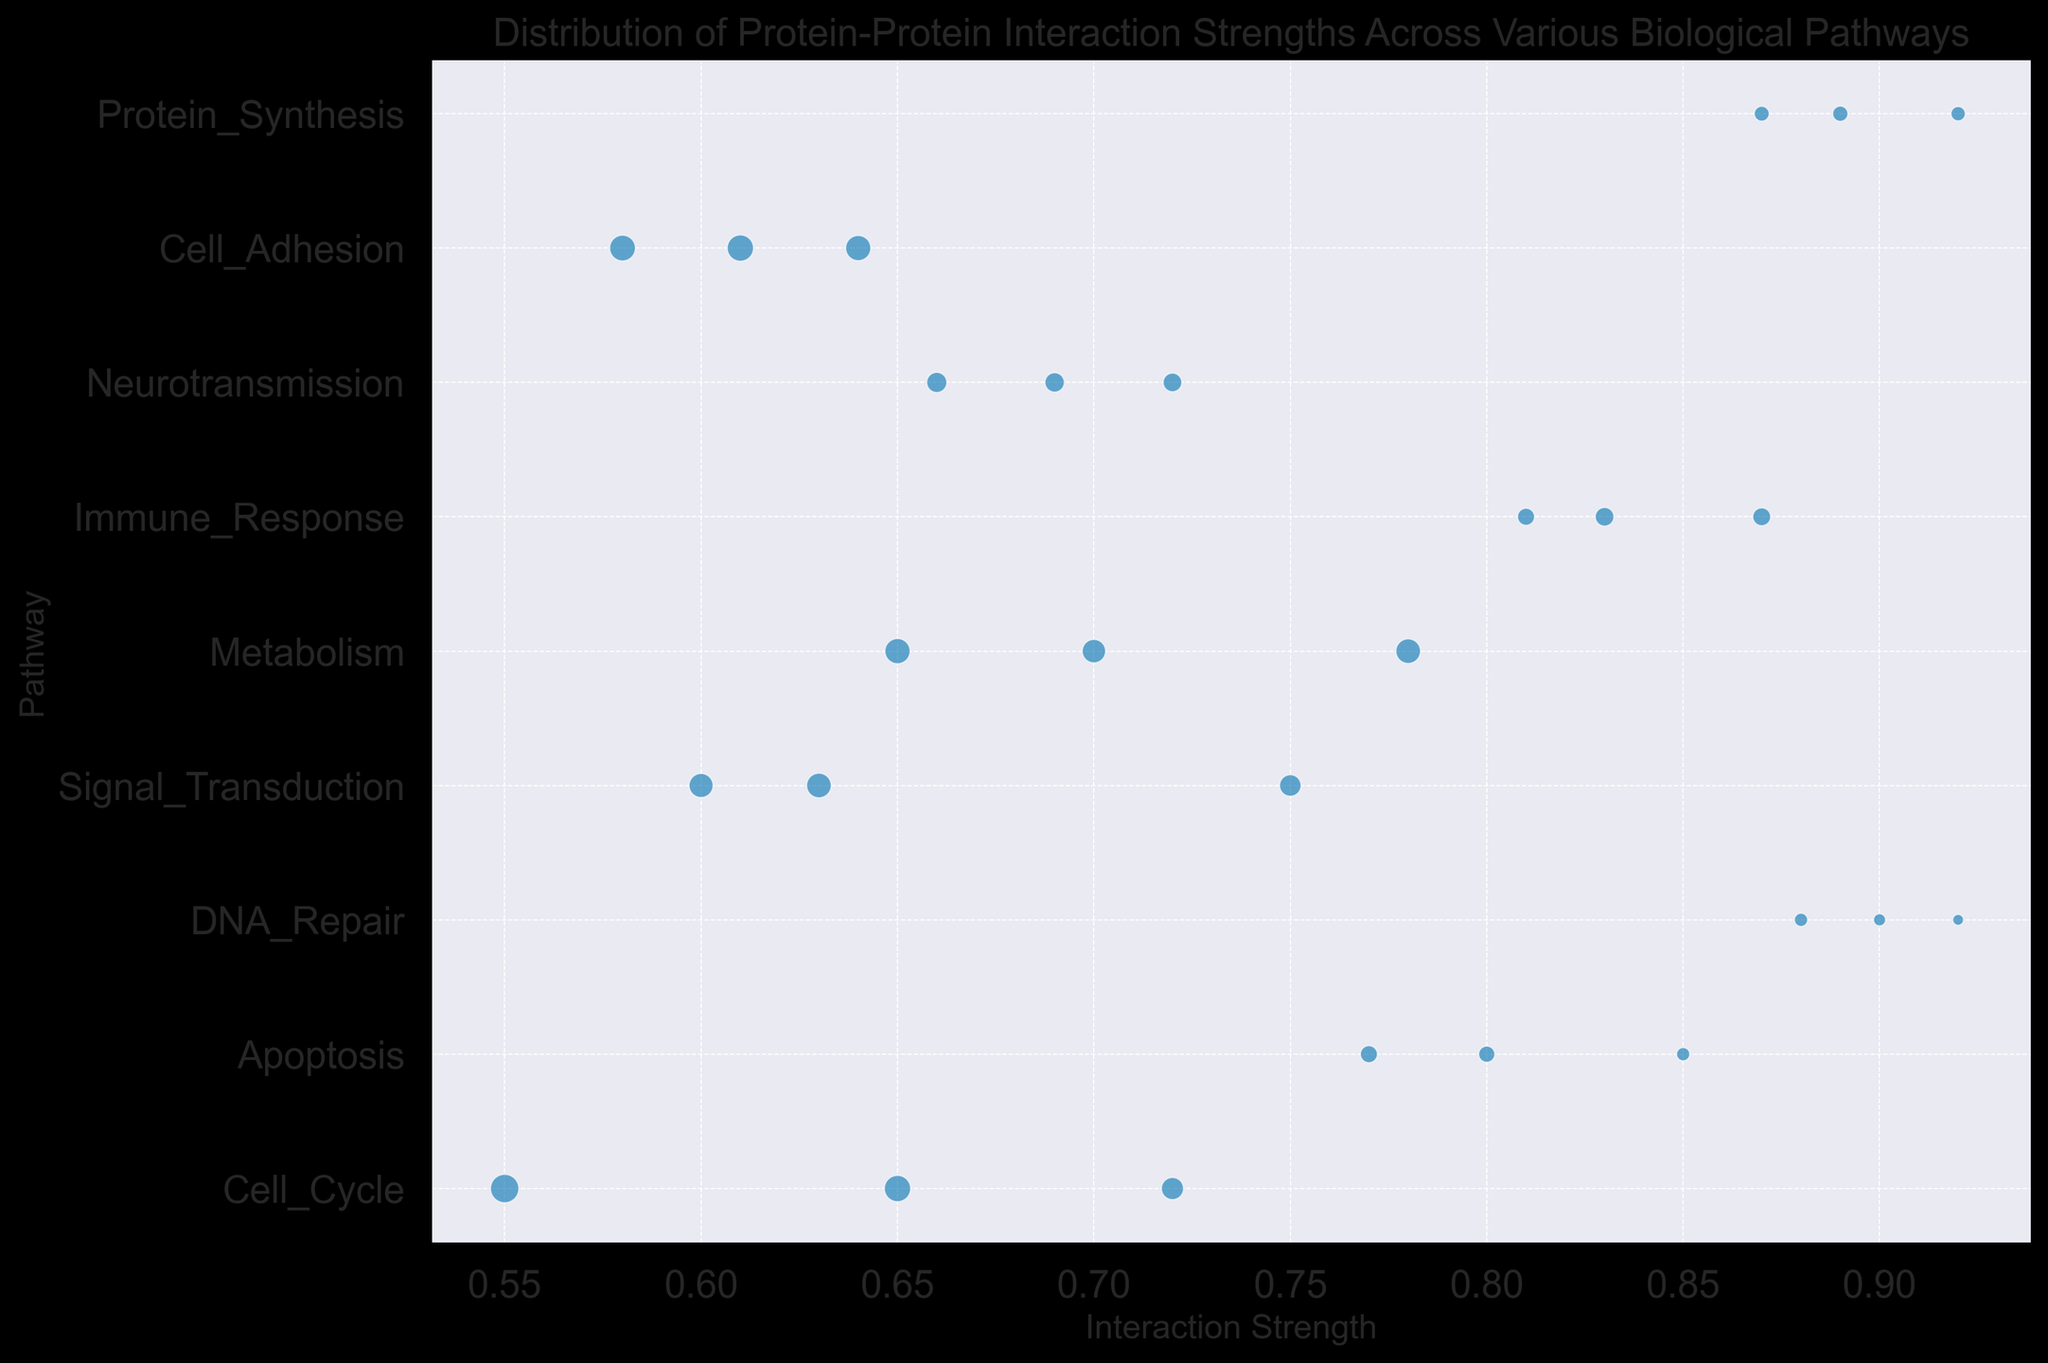What's the pathway with the highest recorded interaction strength? Looking at the y-axis for pathways and the x-axis for interaction strength, we notice the highest recorded interaction strength is 0.92, which is associated with DNA_Repair and Protein_Synthesis pathways.
Answer: DNA_Repair, Protein_Synthesis Which pathway has the greatest range of interaction strengths? To find the range, we look at the difference between the maximum and minimum interaction strengths for each pathway. The Cell_Cycle pathway spans from 0.55 to 0.72.
Answer: Cell_Cycle Which pathways share a similar range of interaction strengths? Observing the x-positions of the bubbles for each pathway, Apoptosis (0.77 to 0.85) and Immune_Response (0.81 to 0.87) have similar interaction strength ranges.
Answer: Apoptosis, Immune_Response Which pathway has the largest bubble (indicating the highest number of interactions)? By examining the size of the bubbles, the largest bubble is in the Cell_Adhesion pathway.
Answer: Cell_Adhesion In which pathway do the interactions have the most variation? To find this, we need to identify the pathway with the widest spread of interaction strength bubbles. Cell_Cycle shows significant spreading in interaction strengths.
Answer: Cell_Cycle Which pathway has interactions generally clustering towards lower interaction strengths? Observing the leftmost positioned pathways on the x-axis, Cell_Adhesion and Signal_Transduction cluster towards lower interaction strengths.
Answer: Cell_Adhesion, Signal_Transduction How does the interaction strength for DNA_Repair compare to Neurotransmission? Comparing the interaction strength positions, DNA_Repair generally has higher interaction strengths than Neurotransmission.
Answer: DNA_Repair has higher strengths Which pathways have an interaction strength above 0.80? Observe the x-axis positions above 0.80 within the range; Apoptosis, DNA_Repair, and Immune_Response all meet this criterion.
Answer: Apoptosis, DNA_Repair, Immune_Response 